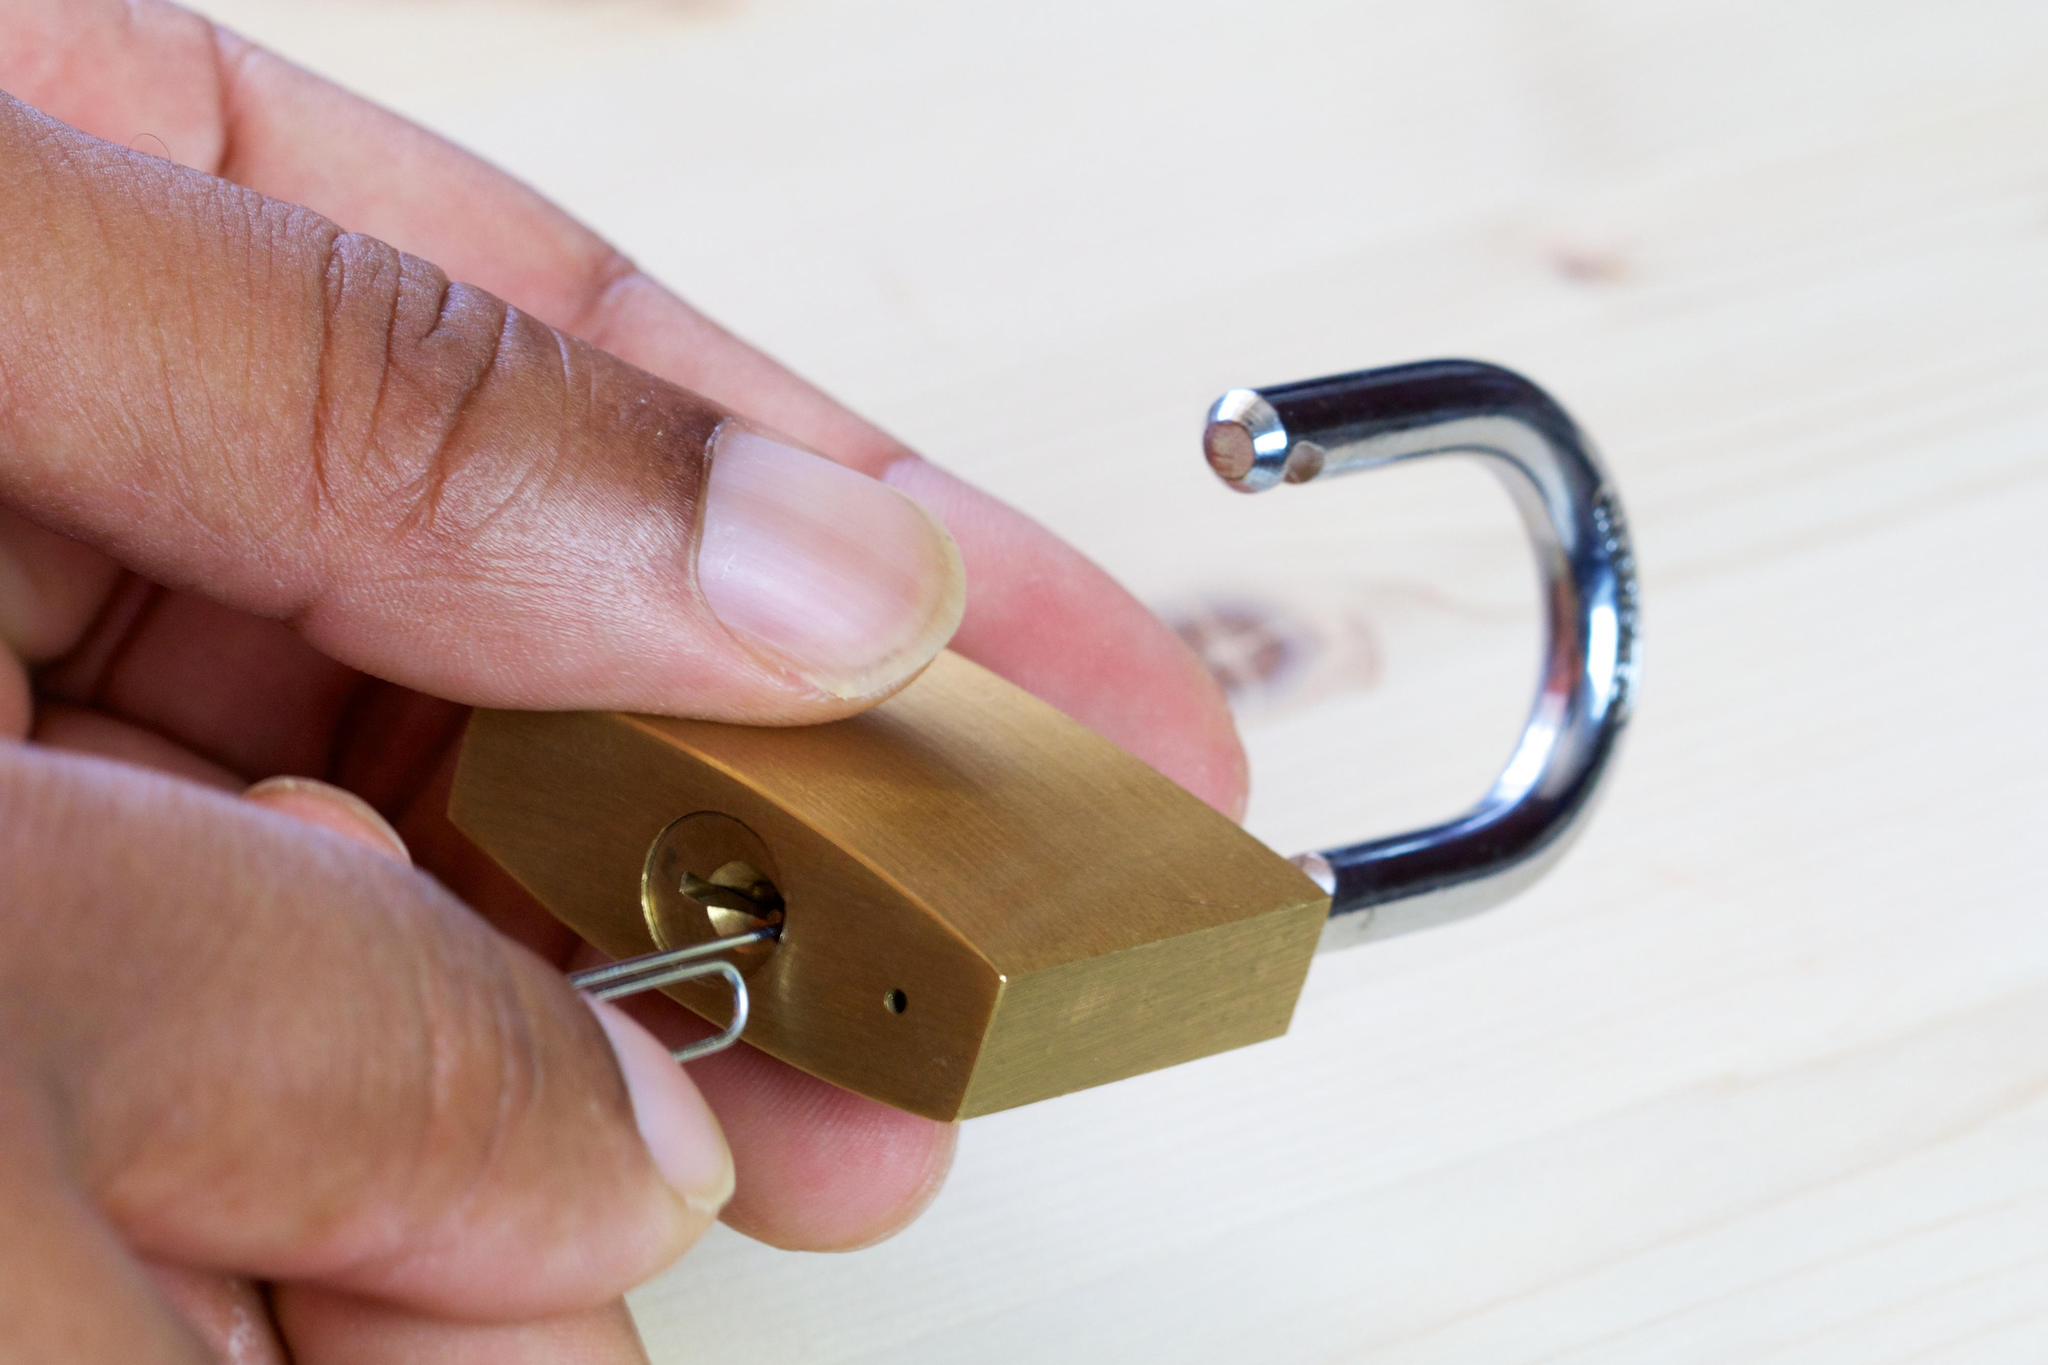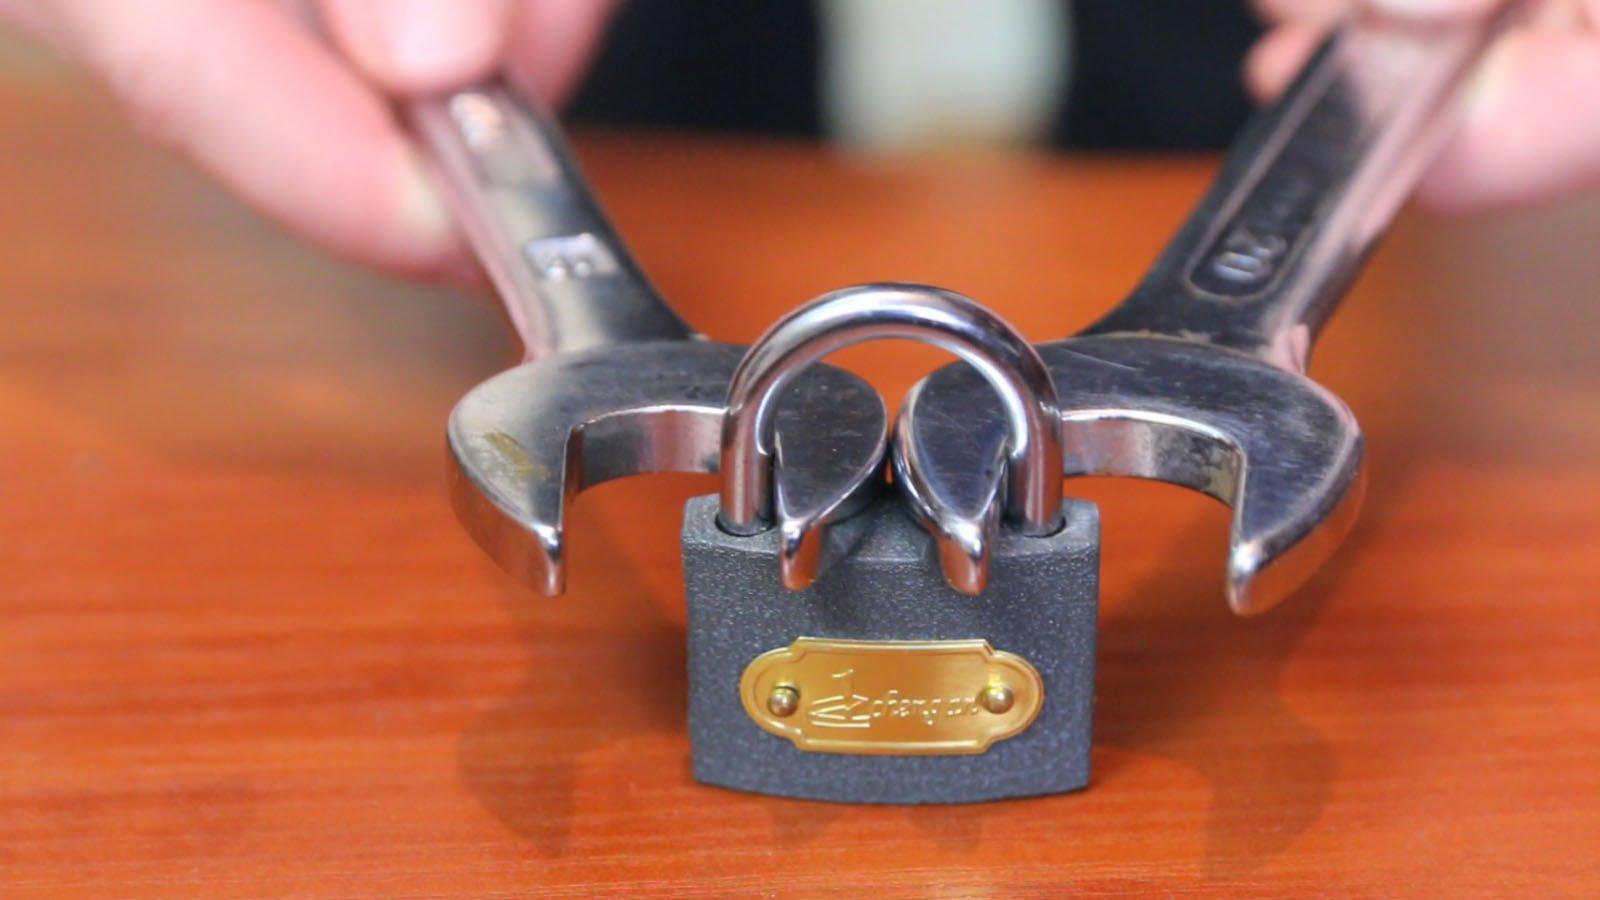The first image is the image on the left, the second image is the image on the right. For the images shown, is this caption "The right image shows a hand inserting something pointed into the keyhole." true? Answer yes or no. No. 